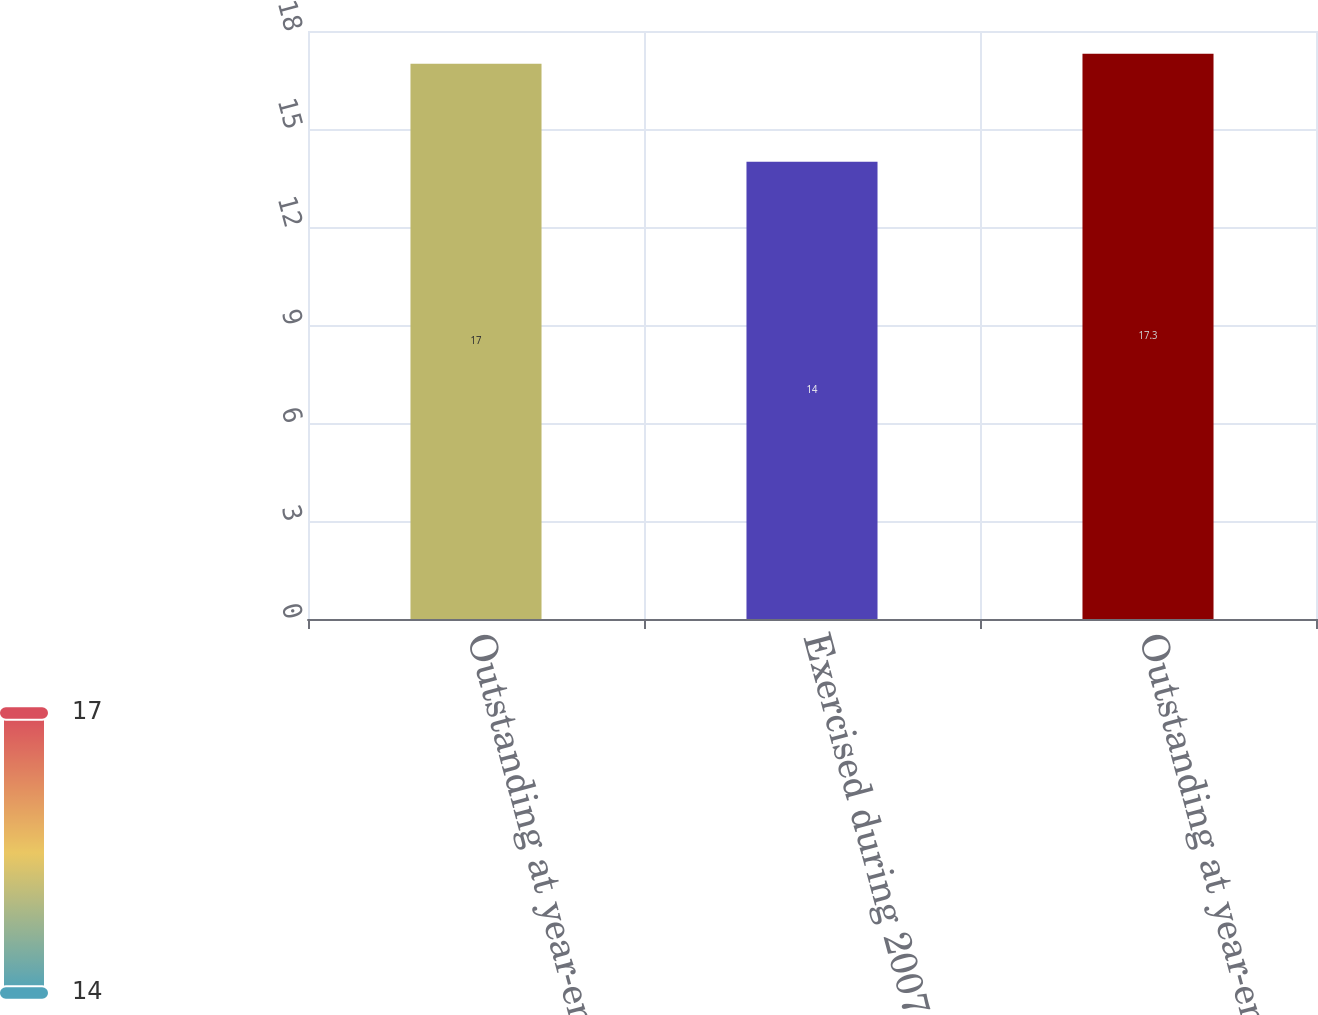Convert chart. <chart><loc_0><loc_0><loc_500><loc_500><bar_chart><fcel>Outstanding at year-end 2006<fcel>Exercised during 2007<fcel>Outstanding at year-end 2007<nl><fcel>17<fcel>14<fcel>17.3<nl></chart> 